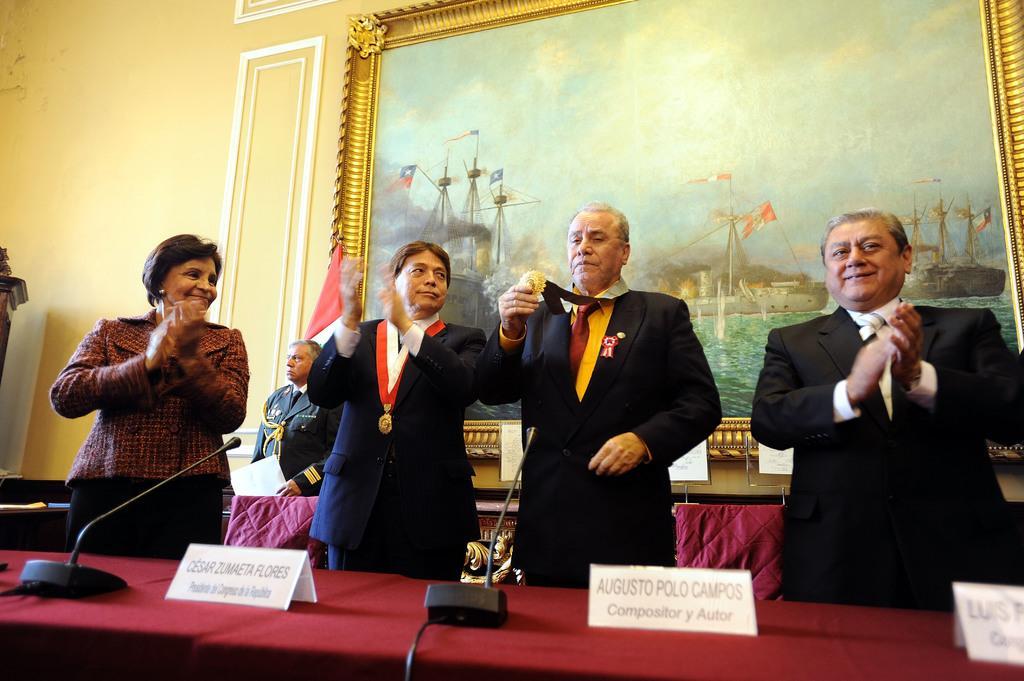In one or two sentences, can you explain what this image depicts? In this image we can see many persons standing at the table. On the table we can see name boards and mics. In the background we can see person, painting and wall. 